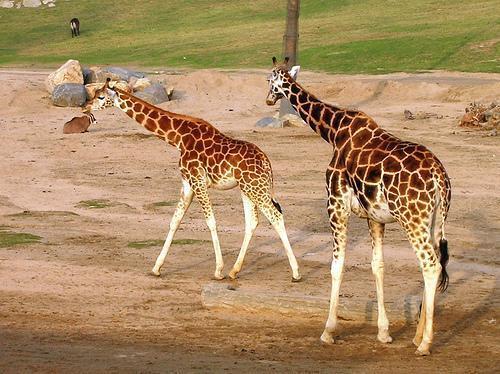How many types of animals are there?
Give a very brief answer. 2. How many trees are in the photo?
Give a very brief answer. 1. 